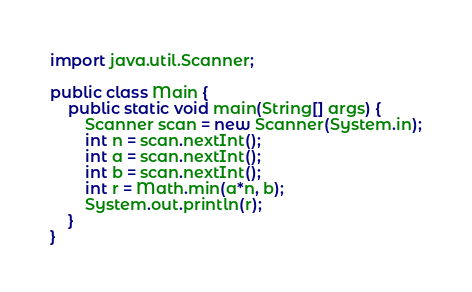Convert code to text. <code><loc_0><loc_0><loc_500><loc_500><_Java_>import java.util.Scanner;

public class Main {	
	public static void main(String[] args) {
		Scanner scan = new Scanner(System.in);
		int n = scan.nextInt();
		int a = scan.nextInt();
		int b = scan.nextInt();
		int r = Math.min(a*n, b);
		System.out.println(r);
	}
}
</code> 